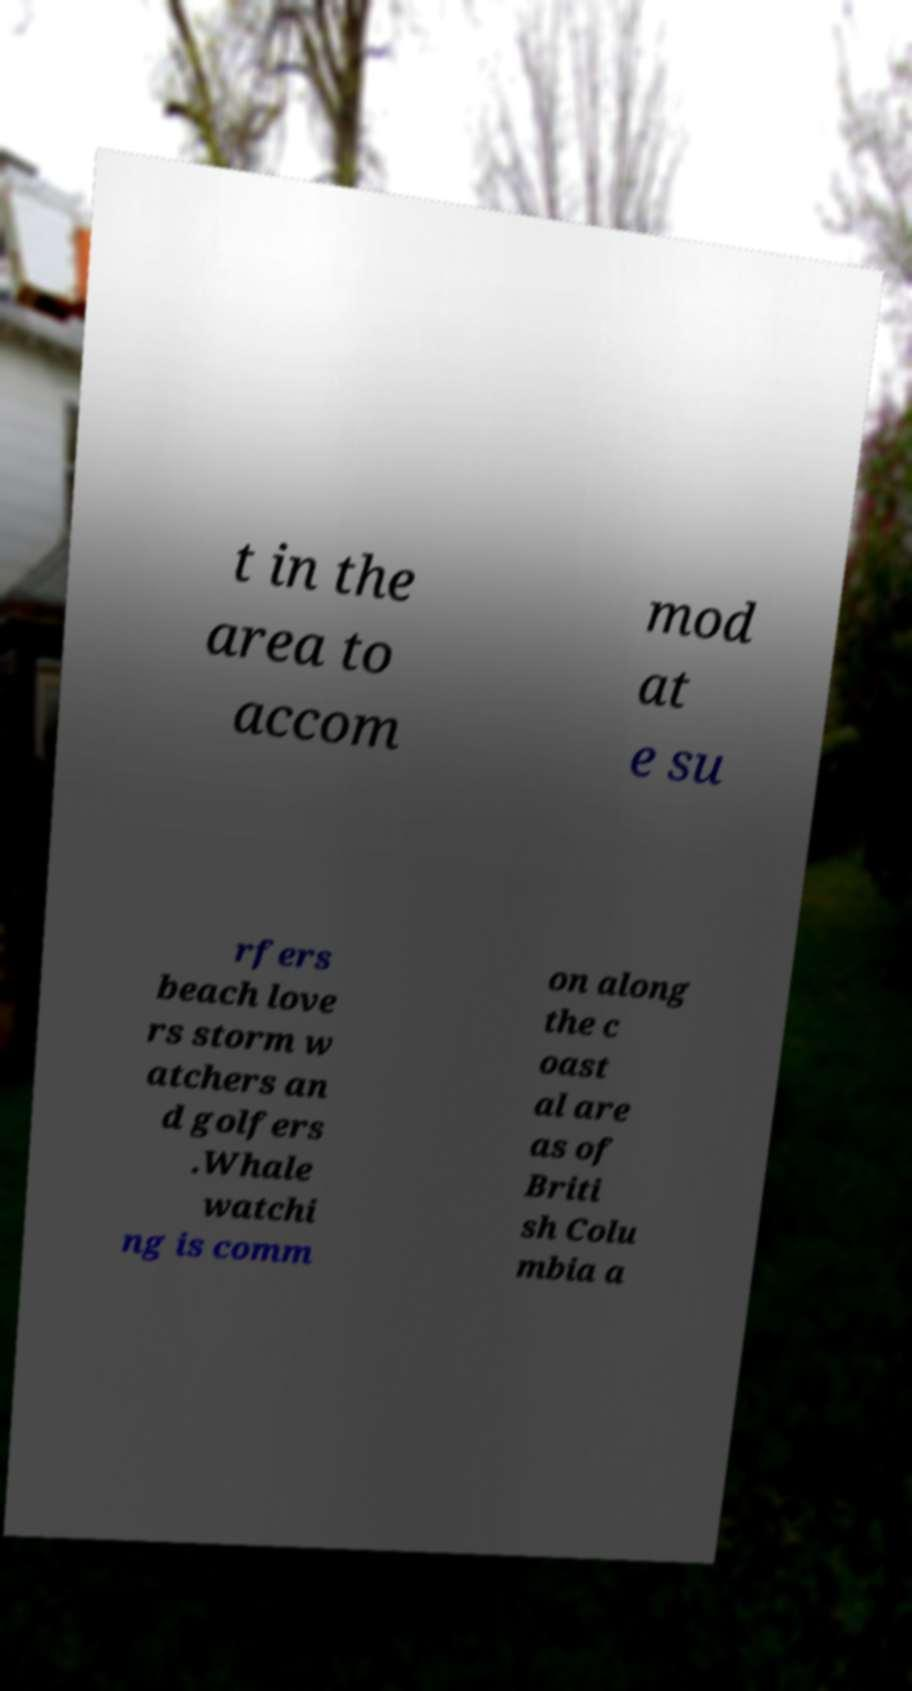There's text embedded in this image that I need extracted. Can you transcribe it verbatim? t in the area to accom mod at e su rfers beach love rs storm w atchers an d golfers .Whale watchi ng is comm on along the c oast al are as of Briti sh Colu mbia a 